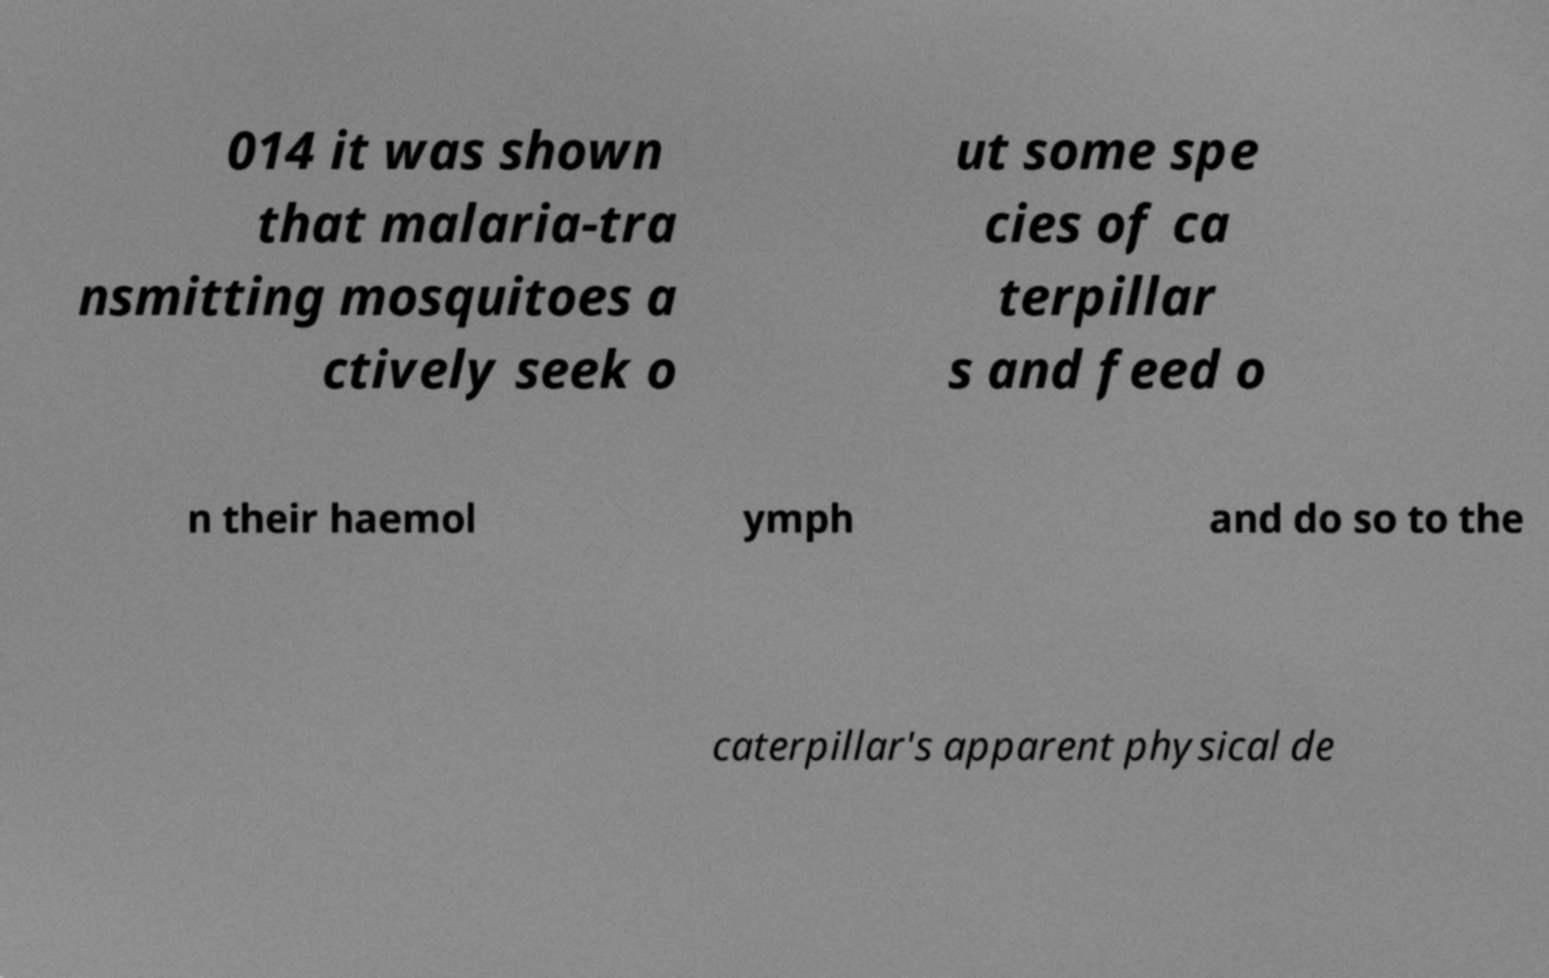Could you extract and type out the text from this image? 014 it was shown that malaria-tra nsmitting mosquitoes a ctively seek o ut some spe cies of ca terpillar s and feed o n their haemol ymph and do so to the caterpillar's apparent physical de 